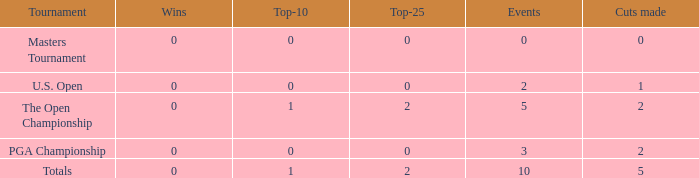What is the sum of top-10s for events with more than 0 wins? None. 